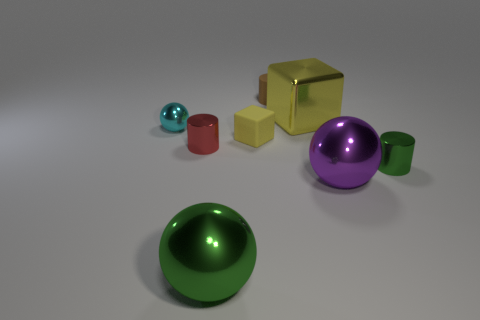Add 1 big green spheres. How many objects exist? 9 Subtract all blocks. How many objects are left? 6 Add 2 metal balls. How many metal balls are left? 5 Add 2 purple metal objects. How many purple metal objects exist? 3 Subtract 1 purple spheres. How many objects are left? 7 Subtract all tiny red rubber blocks. Subtract all balls. How many objects are left? 5 